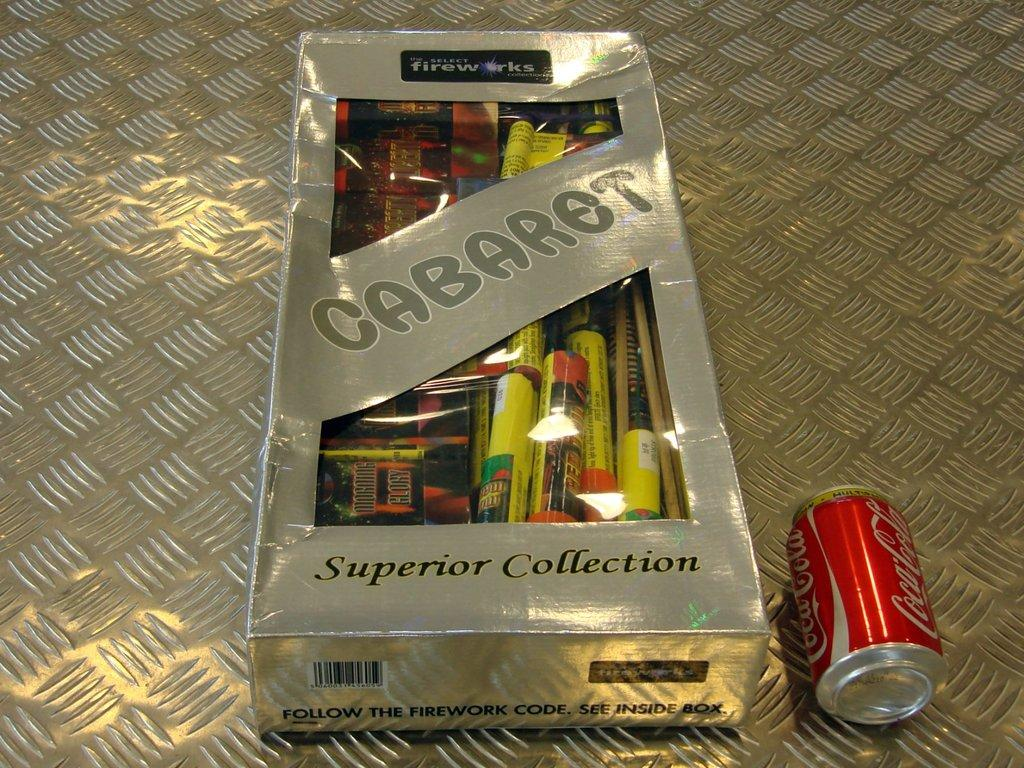<image>
Write a terse but informative summary of the picture. The firework collection shown is a superior collection. 